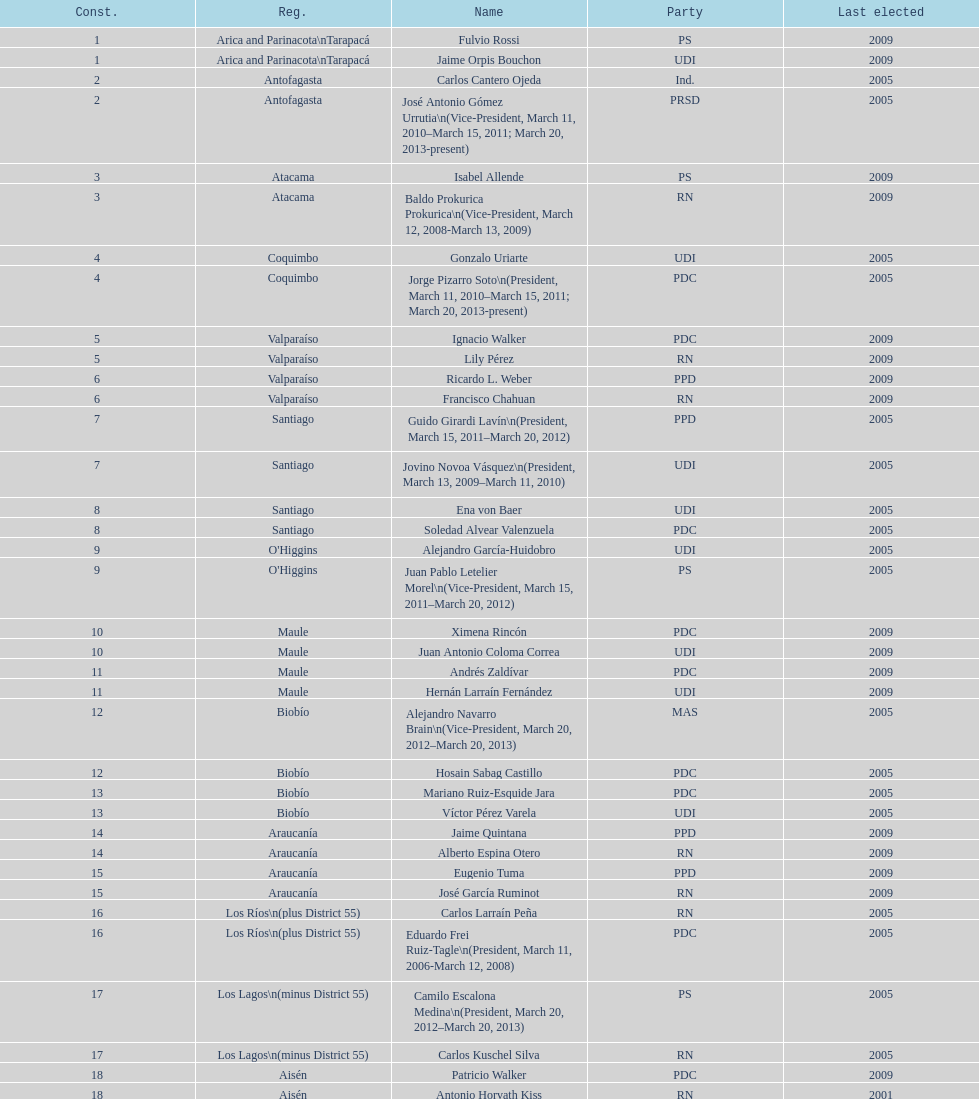When was antonio horvath kiss last elected? 2001. 